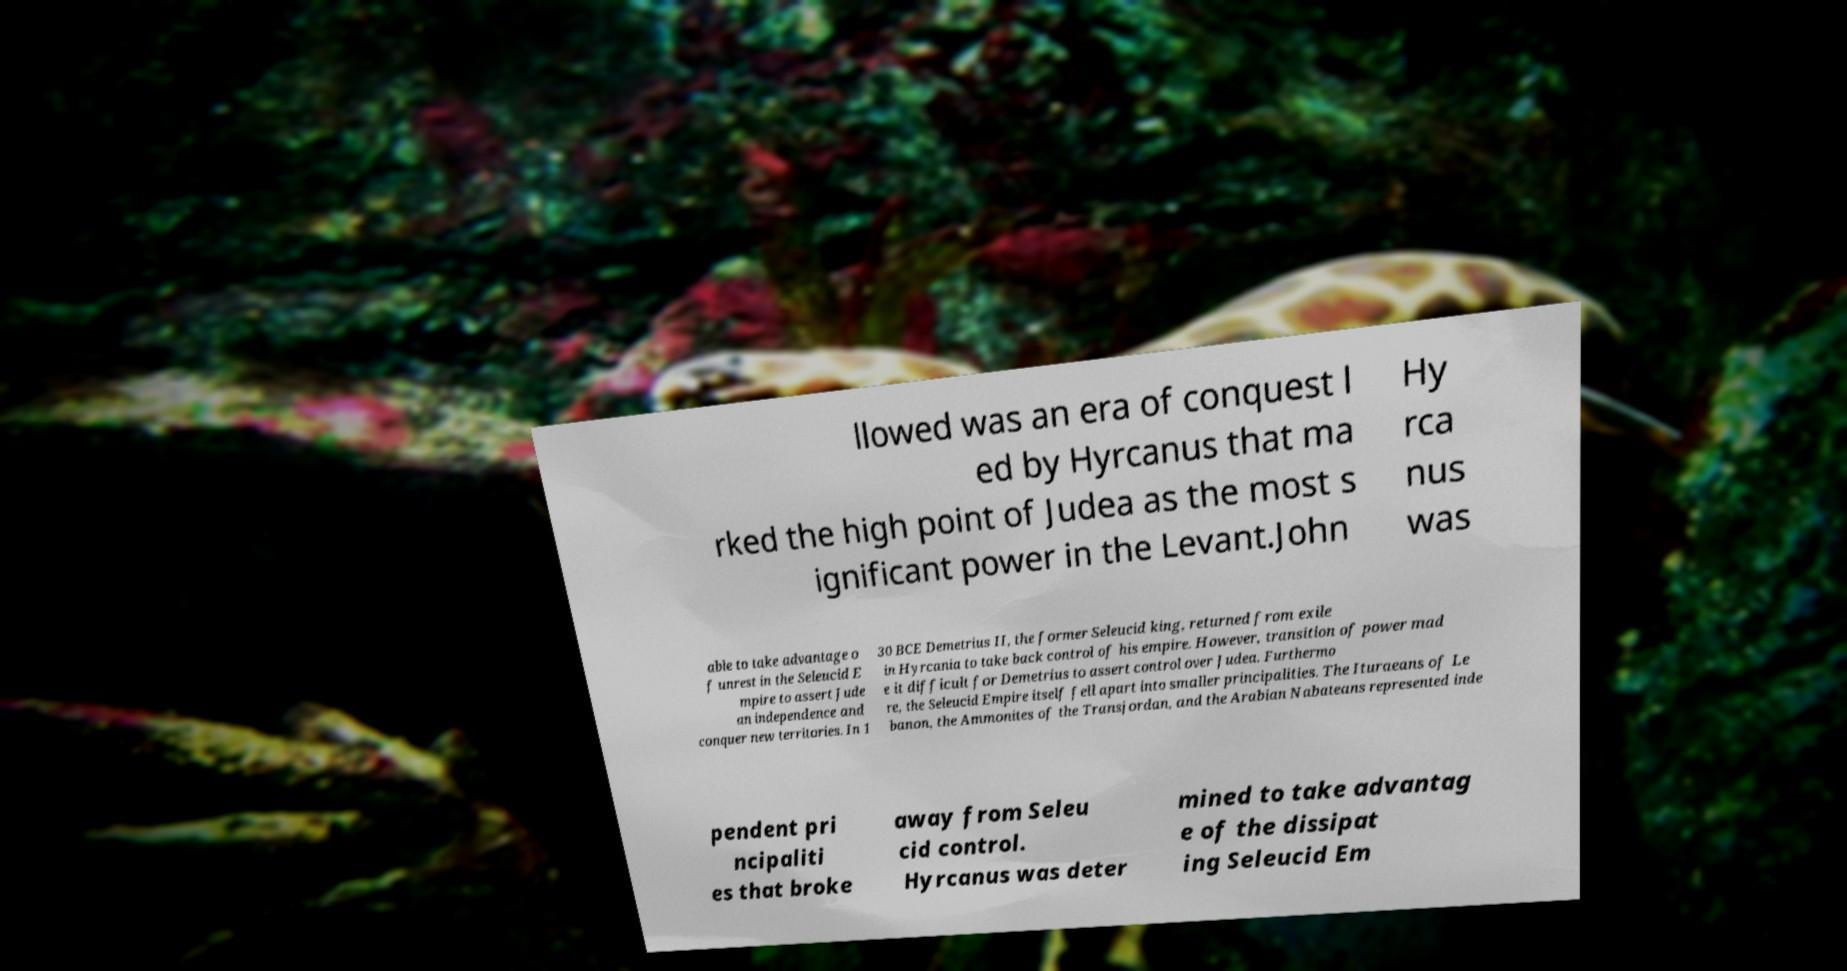There's text embedded in this image that I need extracted. Can you transcribe it verbatim? llowed was an era of conquest l ed by Hyrcanus that ma rked the high point of Judea as the most s ignificant power in the Levant.John Hy rca nus was able to take advantage o f unrest in the Seleucid E mpire to assert Jude an independence and conquer new territories. In 1 30 BCE Demetrius II, the former Seleucid king, returned from exile in Hyrcania to take back control of his empire. However, transition of power mad e it difficult for Demetrius to assert control over Judea. Furthermo re, the Seleucid Empire itself fell apart into smaller principalities. The Ituraeans of Le banon, the Ammonites of the Transjordan, and the Arabian Nabateans represented inde pendent pri ncipaliti es that broke away from Seleu cid control. Hyrcanus was deter mined to take advantag e of the dissipat ing Seleucid Em 